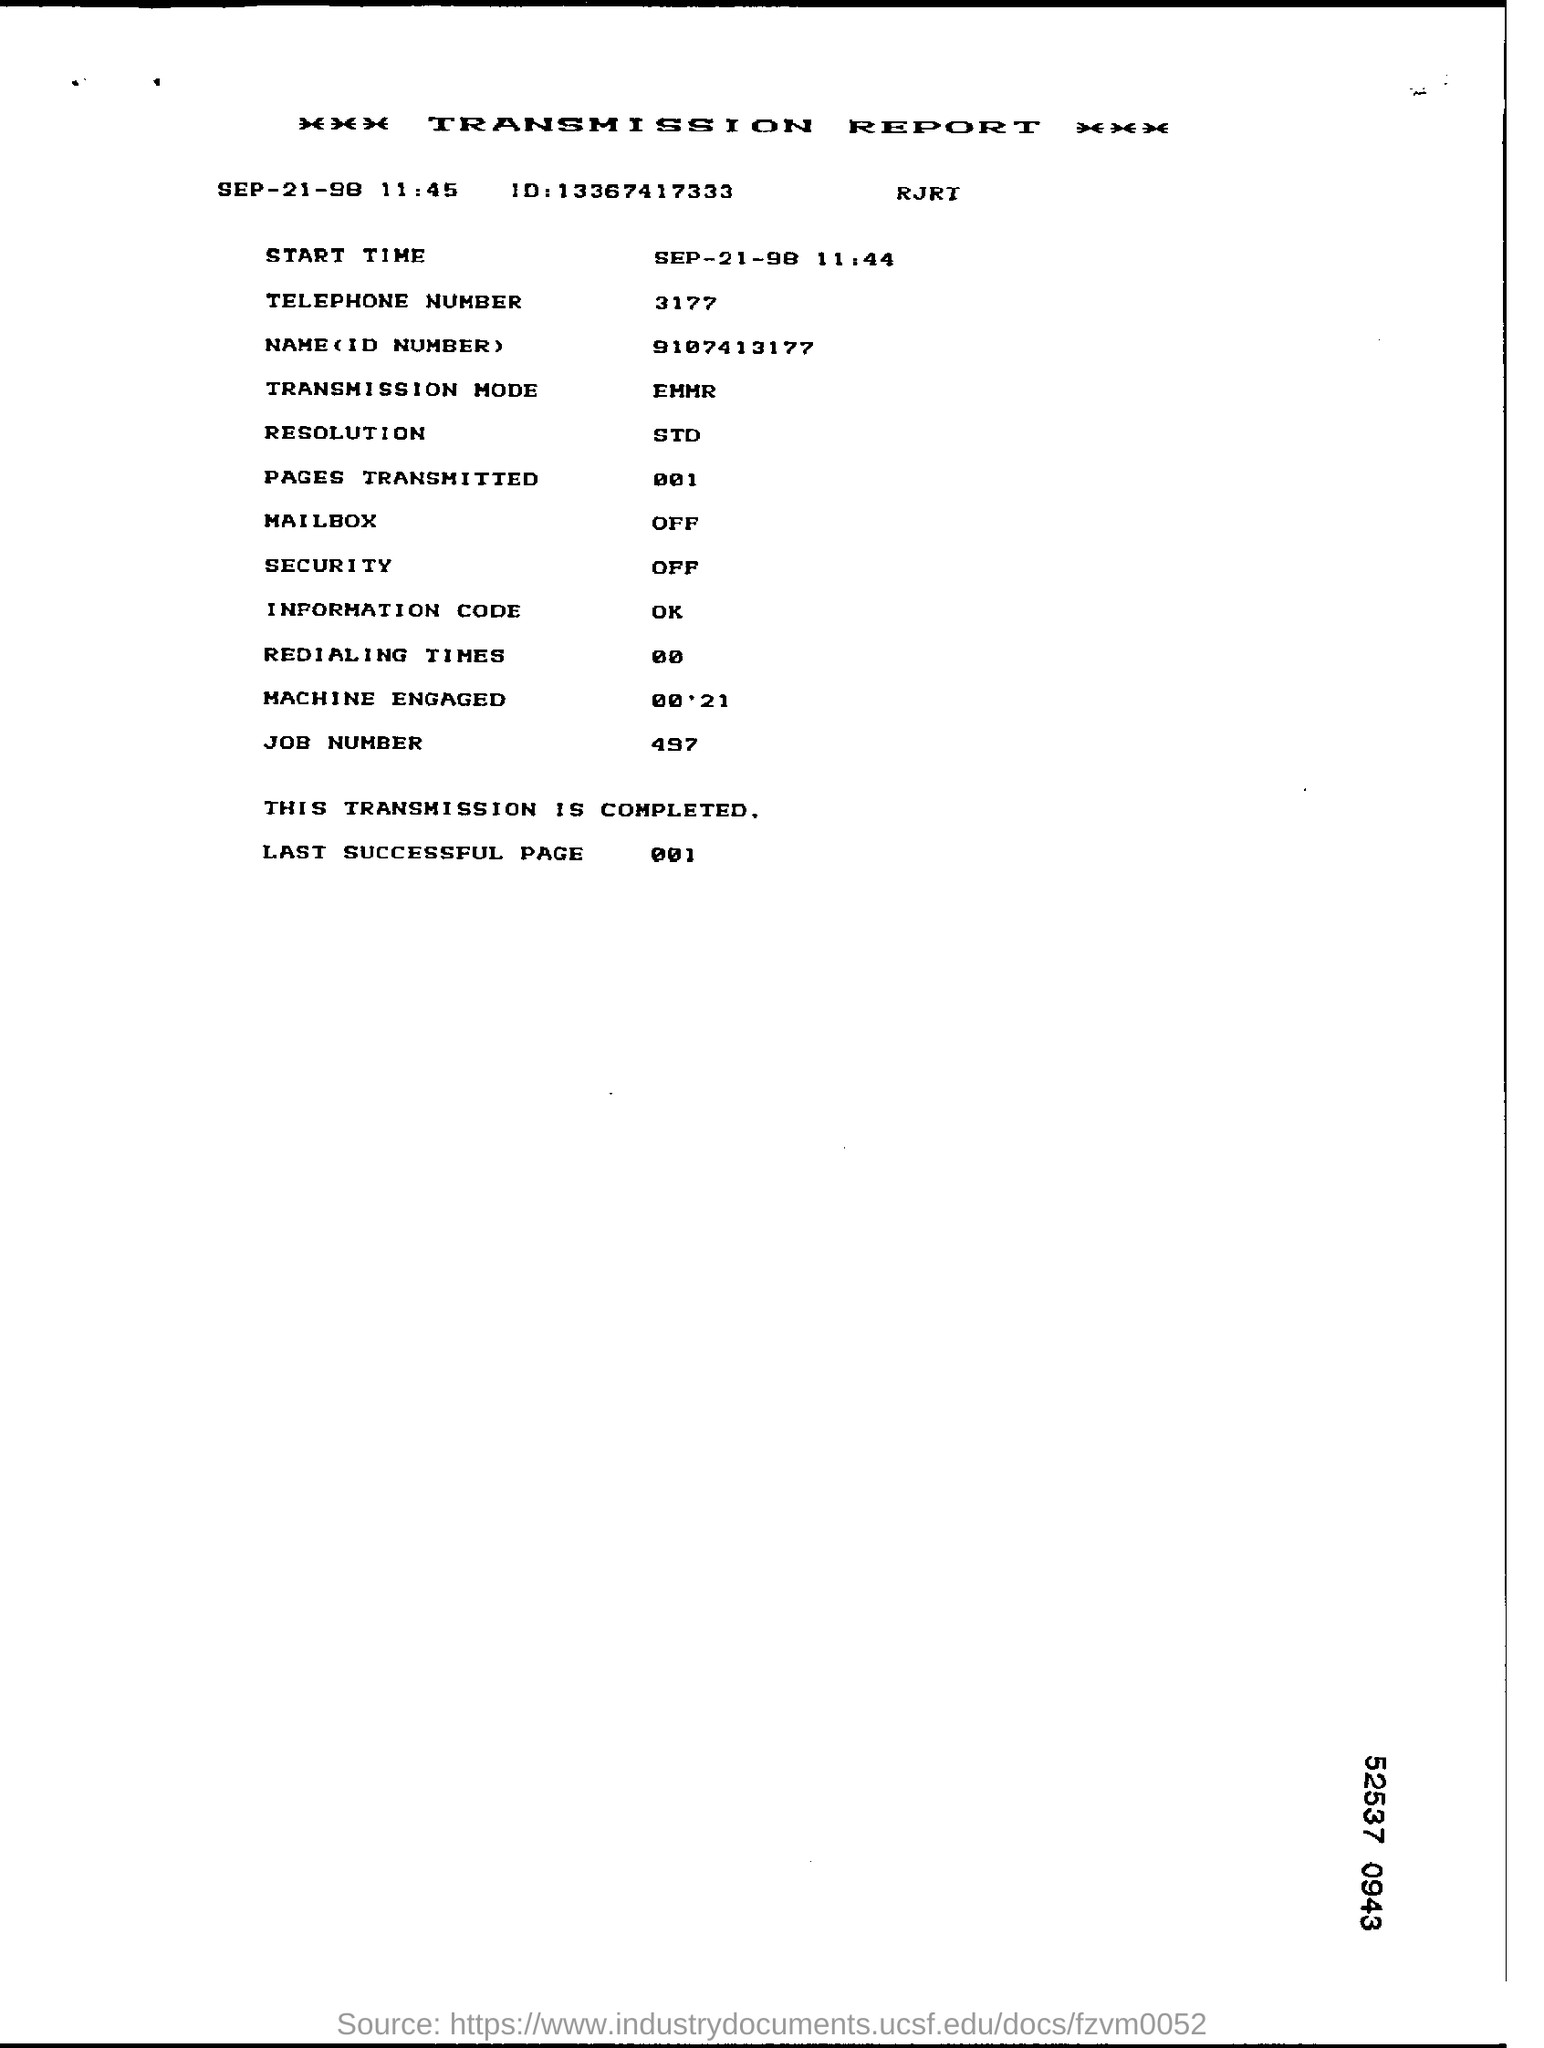Draw attention to some important aspects in this diagram. Four hundred ninety-seven is a type of number commonly used for job numbers. The telephone number mentioned in the report is 3177... The last successful page number as per the report is 001. The transmission report is the heading of this document. 